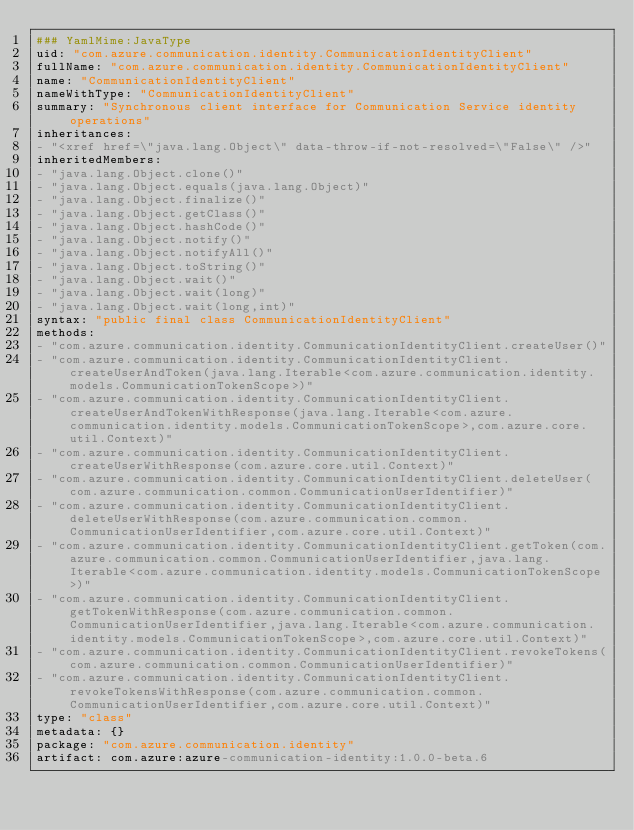<code> <loc_0><loc_0><loc_500><loc_500><_YAML_>### YamlMime:JavaType
uid: "com.azure.communication.identity.CommunicationIdentityClient"
fullName: "com.azure.communication.identity.CommunicationIdentityClient"
name: "CommunicationIdentityClient"
nameWithType: "CommunicationIdentityClient"
summary: "Synchronous client interface for Communication Service identity operations"
inheritances:
- "<xref href=\"java.lang.Object\" data-throw-if-not-resolved=\"False\" />"
inheritedMembers:
- "java.lang.Object.clone()"
- "java.lang.Object.equals(java.lang.Object)"
- "java.lang.Object.finalize()"
- "java.lang.Object.getClass()"
- "java.lang.Object.hashCode()"
- "java.lang.Object.notify()"
- "java.lang.Object.notifyAll()"
- "java.lang.Object.toString()"
- "java.lang.Object.wait()"
- "java.lang.Object.wait(long)"
- "java.lang.Object.wait(long,int)"
syntax: "public final class CommunicationIdentityClient"
methods:
- "com.azure.communication.identity.CommunicationIdentityClient.createUser()"
- "com.azure.communication.identity.CommunicationIdentityClient.createUserAndToken(java.lang.Iterable<com.azure.communication.identity.models.CommunicationTokenScope>)"
- "com.azure.communication.identity.CommunicationIdentityClient.createUserAndTokenWithResponse(java.lang.Iterable<com.azure.communication.identity.models.CommunicationTokenScope>,com.azure.core.util.Context)"
- "com.azure.communication.identity.CommunicationIdentityClient.createUserWithResponse(com.azure.core.util.Context)"
- "com.azure.communication.identity.CommunicationIdentityClient.deleteUser(com.azure.communication.common.CommunicationUserIdentifier)"
- "com.azure.communication.identity.CommunicationIdentityClient.deleteUserWithResponse(com.azure.communication.common.CommunicationUserIdentifier,com.azure.core.util.Context)"
- "com.azure.communication.identity.CommunicationIdentityClient.getToken(com.azure.communication.common.CommunicationUserIdentifier,java.lang.Iterable<com.azure.communication.identity.models.CommunicationTokenScope>)"
- "com.azure.communication.identity.CommunicationIdentityClient.getTokenWithResponse(com.azure.communication.common.CommunicationUserIdentifier,java.lang.Iterable<com.azure.communication.identity.models.CommunicationTokenScope>,com.azure.core.util.Context)"
- "com.azure.communication.identity.CommunicationIdentityClient.revokeTokens(com.azure.communication.common.CommunicationUserIdentifier)"
- "com.azure.communication.identity.CommunicationIdentityClient.revokeTokensWithResponse(com.azure.communication.common.CommunicationUserIdentifier,com.azure.core.util.Context)"
type: "class"
metadata: {}
package: "com.azure.communication.identity"
artifact: com.azure:azure-communication-identity:1.0.0-beta.6
</code> 